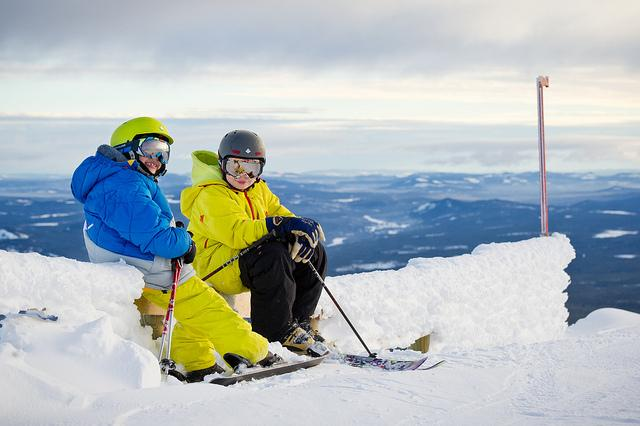What are they doing? sitting 